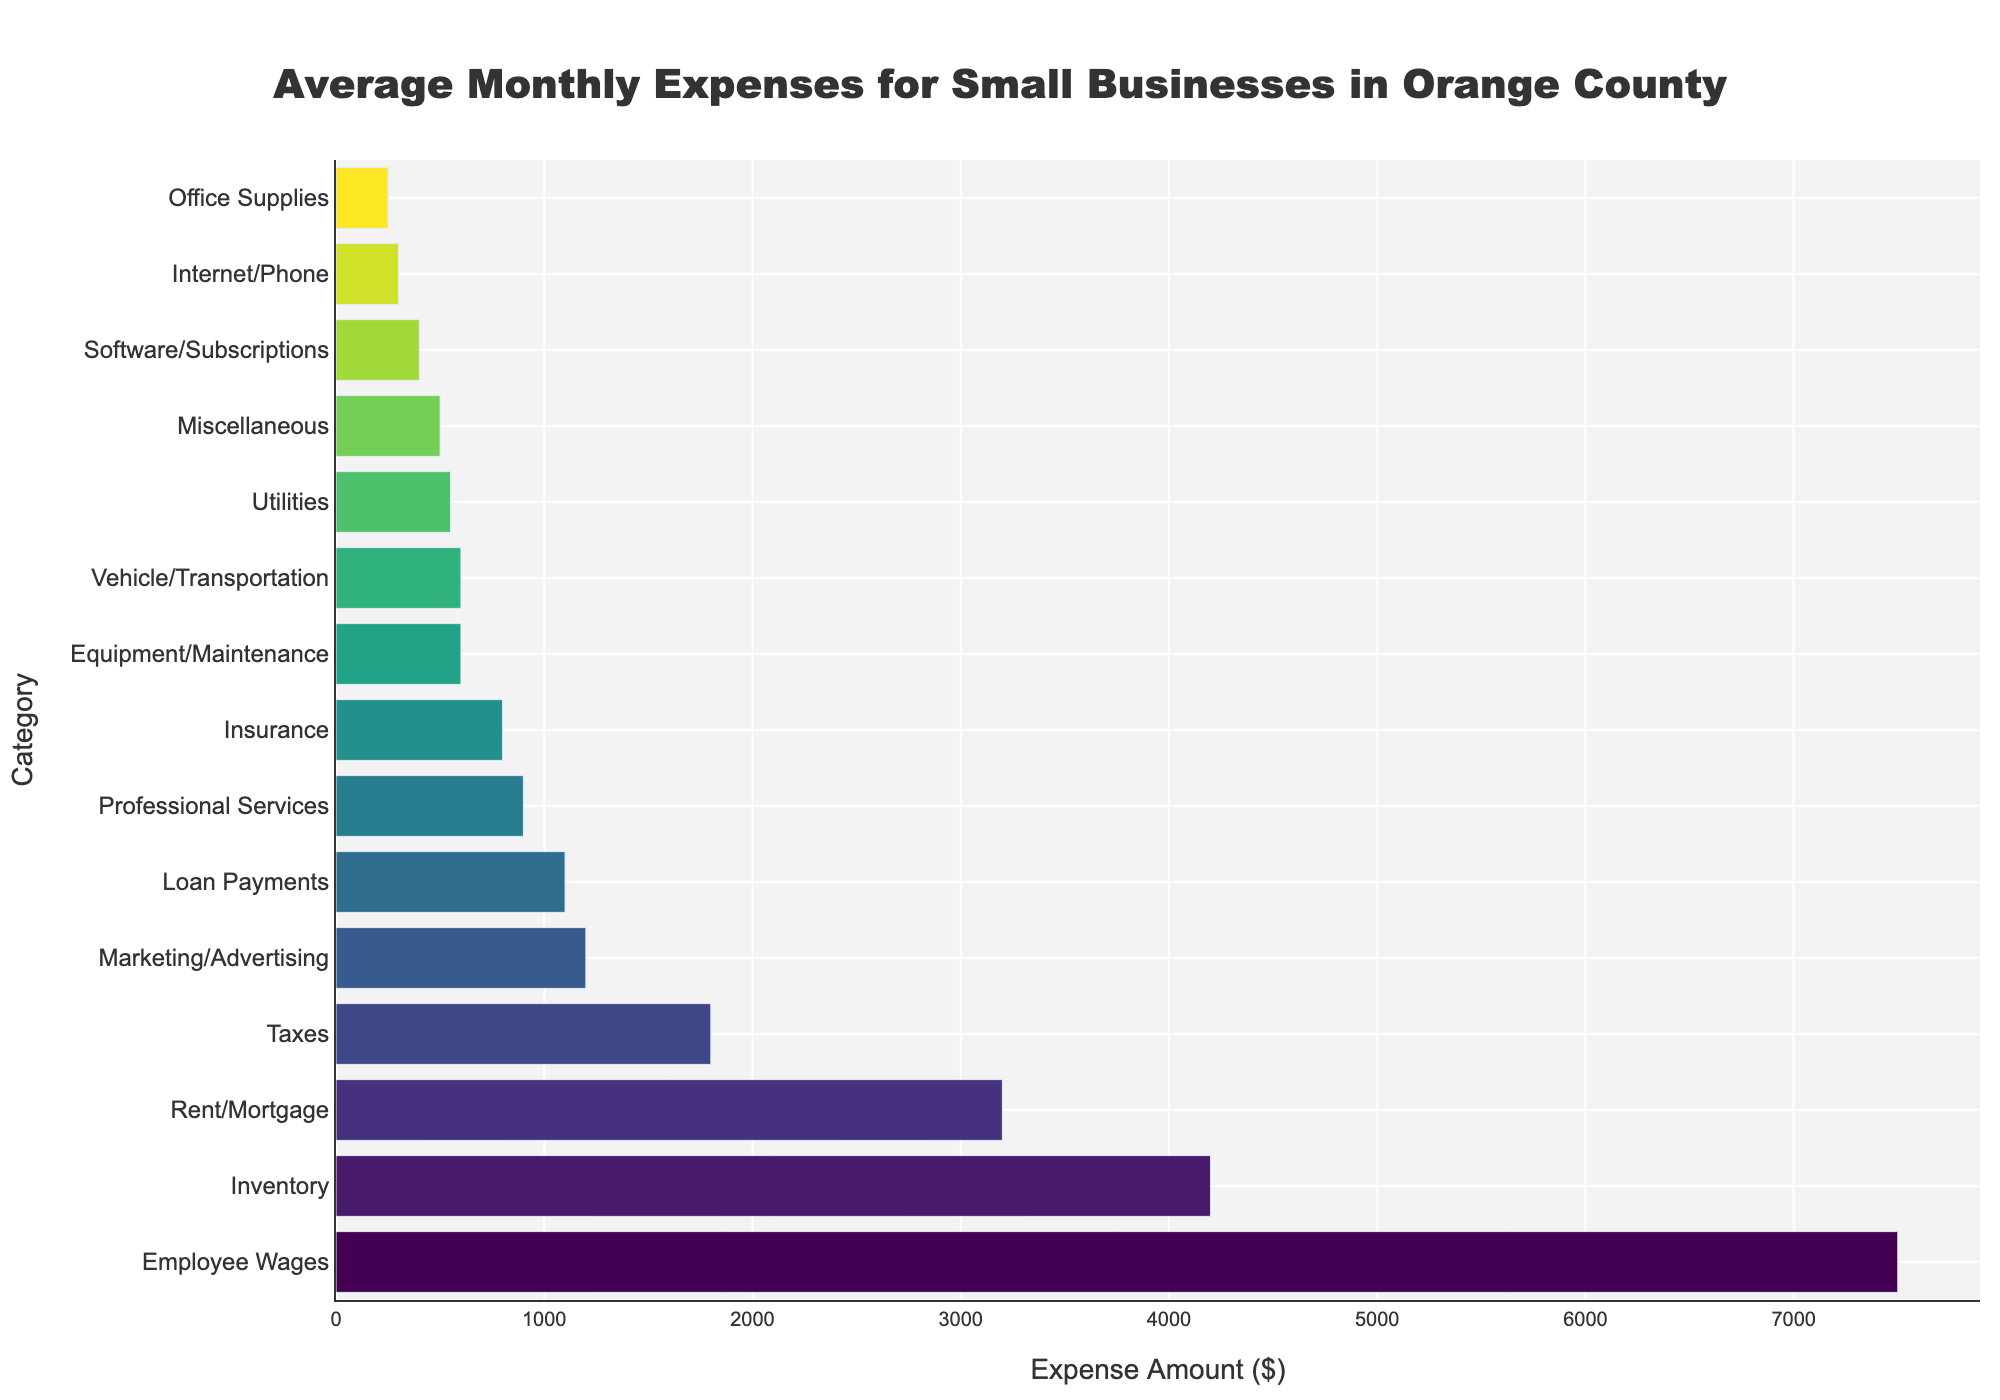What is the highest average monthly expense category for small businesses in Orange County? The highest bar in the chart represents the largest expense, which is 'Employee Wages.' The corresponding value is $7,500.
Answer: Employee Wages Which two categories have the smallest average monthly expenses and what are their values? The two shortest bars in the chart represent the smallest expenses: 'Office Supplies' at $250 and 'Internet/Phone' at $300.
Answer: Office Supplies ($250) and Internet/Phone ($300) What is the combined monthly expense for Rent/Mortgage and Inventory? The respective values for Rent/Mortgage and Inventory from the chart are $3,200 and $4,200. Their sum is $3,200 + $4,200 = $7,400.
Answer: $7,400 Which category has a higher average monthly expense: Marketing/Advertising or Insurance? By how much? Comparing the lengths of the bars, Marketing/Advertising is $1,200 and Insurance is $800. Marketing/Advertising is $1,200 - $800 = $400 higher.
Answer: Marketing/Advertising by $400 What is the average monthly expense for the categories with expenses greater than $1,000? Categories with expenses greater than $1,000 are Rent/Mortgage ($3,200), Employee Wages ($7,500), Inventory ($4,200), Marketing/Advertising ($1,200), Taxes ($1,800), and Loan Payments ($1,100). The sum is $3,200 + $7,500 + $4,200 + $1,200 + $1,800 + $1,100 = $19,000. There are 6 categories, so the average is $19,000 / 6 = $3,167.
Answer: $3,167 How much more is spent on Equipment/Maintenance compared to Office Supplies? The bar for Equipment/Maintenance is $600 while Office Supplies costs $250. The difference is $600 - $250 = $350.
Answer: $350 What is the total monthly expense for categories with expenses less than $600? Categories with expenses less than $600 are Utilities ($550), Equipment/Maintenance ($600), Office Supplies ($250), Internet/Phone ($300), Software/Subscriptions ($400), Vehicle/Transportation ($600), and Miscellaneous ($500). Their sum is $550 + $600 + $250 + $300 + $400 + $600 + $500 = $3,200.
Answer: $3,200 If you wanted to reduce costs, which category would be the most impactful to target? The category with the highest average expense is 'Employee Wages' at $7,500, making it the most impactful to target for cost reduction.
Answer: Employee Wages Which two categories combined make up the second largest group of expenses, and what is their total? Excluding Employee Wages, the next two highest are Inventory ($4,200) and Rent/Mortgage ($3,200). Their total is $4,200 + $3,200 = $7,400.
Answer: Inventory and Rent/Mortgage ($7,400) What trend can you observe about the distribution of average monthly expenses in the chart? The chart shows a clear trend where a few categories like Employee Wages and Inventory account for a large portion of expenses, whereas many smaller expenses are in the lower range between $250 and $900. This highlights a skewed distribution with high variability.
Answer: Skewed distribution with high variability 